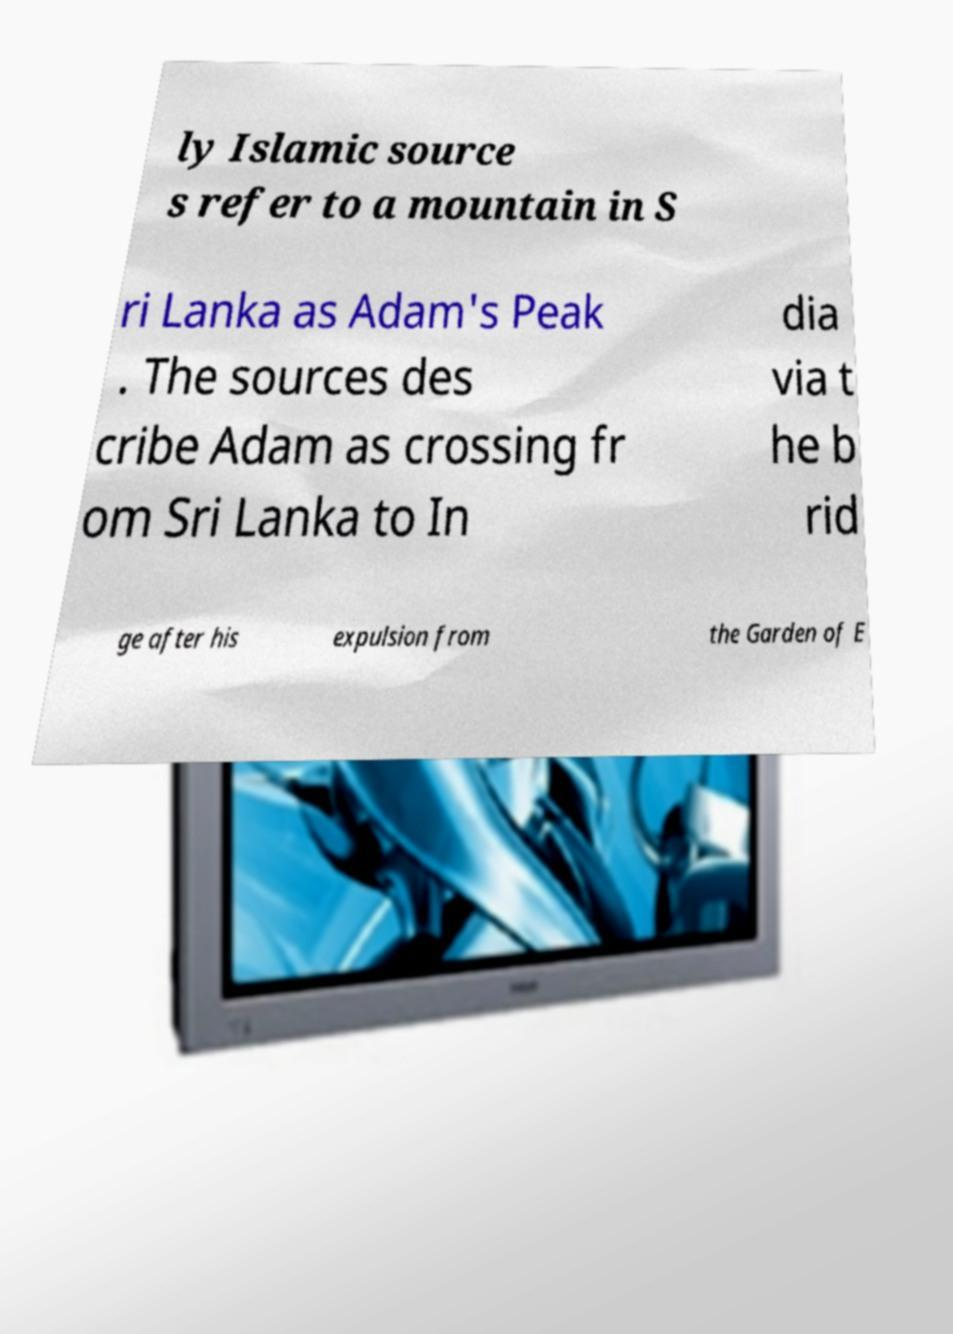Please identify and transcribe the text found in this image. ly Islamic source s refer to a mountain in S ri Lanka as Adam's Peak . The sources des cribe Adam as crossing fr om Sri Lanka to In dia via t he b rid ge after his expulsion from the Garden of E 